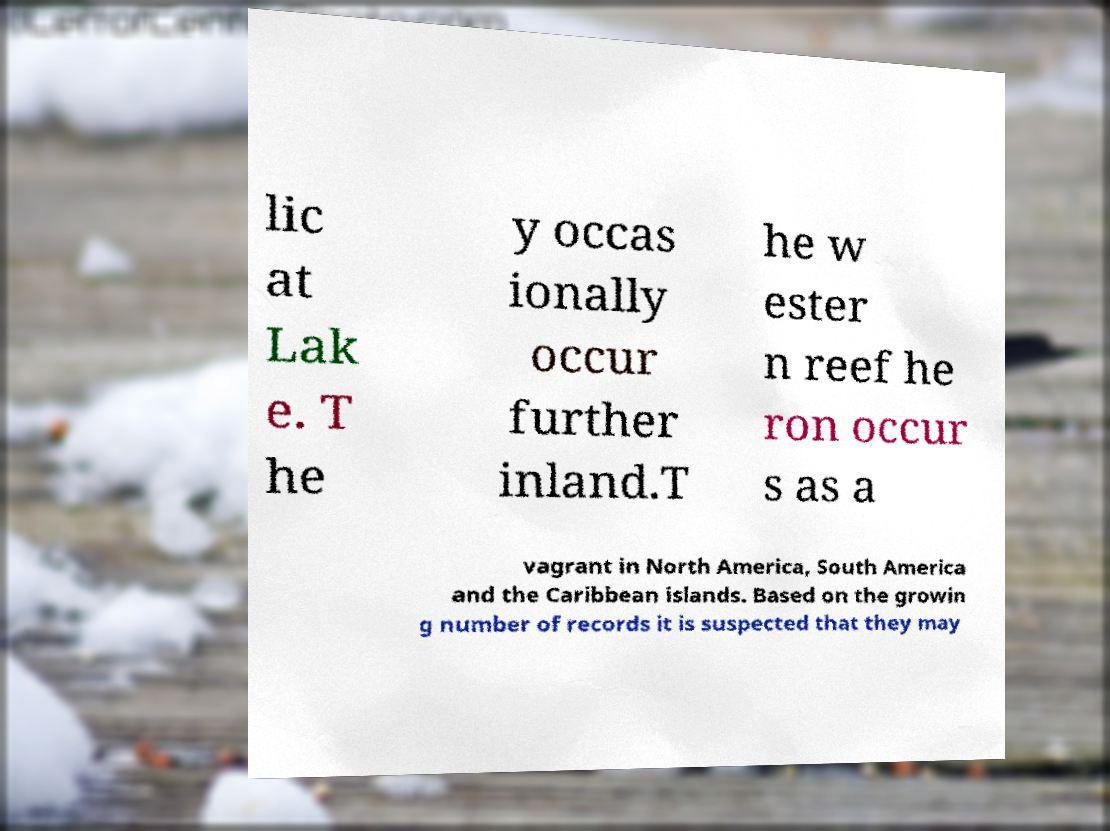There's text embedded in this image that I need extracted. Can you transcribe it verbatim? lic at Lak e. T he y occas ionally occur further inland.T he w ester n reef he ron occur s as a vagrant in North America, South America and the Caribbean islands. Based on the growin g number of records it is suspected that they may 